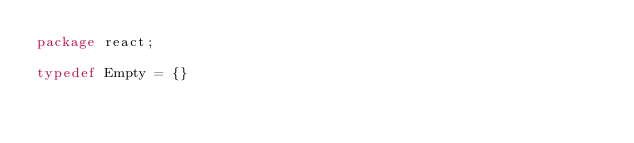Convert code to text. <code><loc_0><loc_0><loc_500><loc_500><_Haxe_>package react;

typedef Empty = {}

</code> 